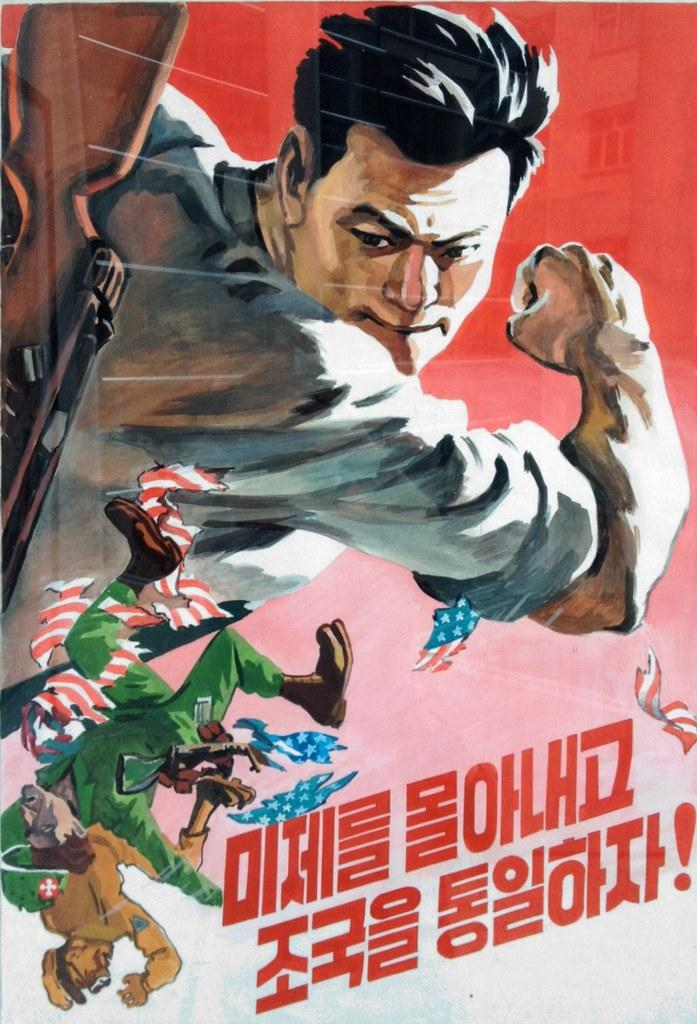What is present in the image that features a visual representation? There is a poster in the image. What type of characters are depicted on the poster? The poster contains cartoons of three persons. Is there any text present on the poster? Yes, there is text on the poster. What type of cave is shown in the background of the poster? There is no cave present in the image, as the poster features cartoons of three persons and text. 